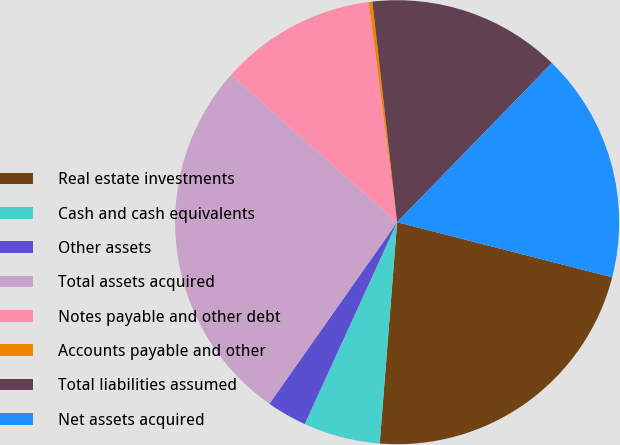Convert chart. <chart><loc_0><loc_0><loc_500><loc_500><pie_chart><fcel>Real estate investments<fcel>Cash and cash equivalents<fcel>Other assets<fcel>Total assets acquired<fcel>Notes payable and other debt<fcel>Accounts payable and other<fcel>Total liabilities assumed<fcel>Net assets acquired<nl><fcel>22.26%<fcel>5.58%<fcel>2.93%<fcel>26.79%<fcel>11.4%<fcel>0.27%<fcel>14.06%<fcel>16.71%<nl></chart> 